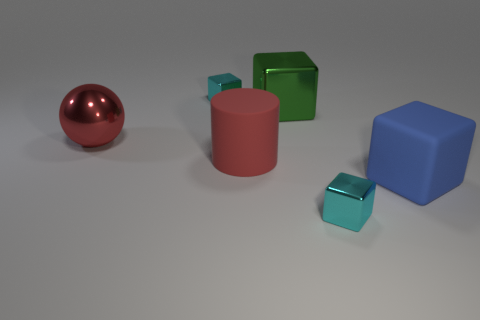What can you infer about the texture and material of these objects? The objects in the image hint at different materials and textures. The red sphere has a metallic sheen, indicating a reflective surface. The cubes and the cylinder look matte, suggesting a non-reflective, possibly plastic material. The smaller cubes have a slight transparency, which may imply they are made of glass or a similar material. 